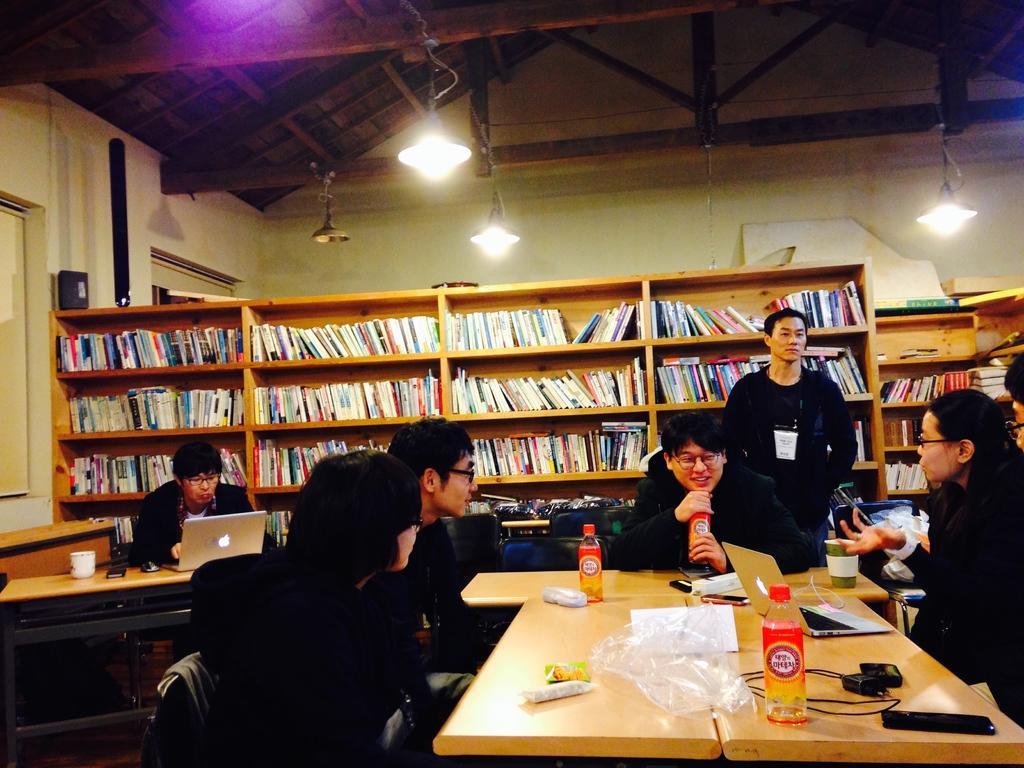Can you describe this image briefly? In this picture we can see a group of people sitting on chairs, one person is standing, here we can see tables, laptops, bottles, mobile phones, battery, cups, paper and some objects and in the background we can see a wall, racks, books, windows, lights, roof. 